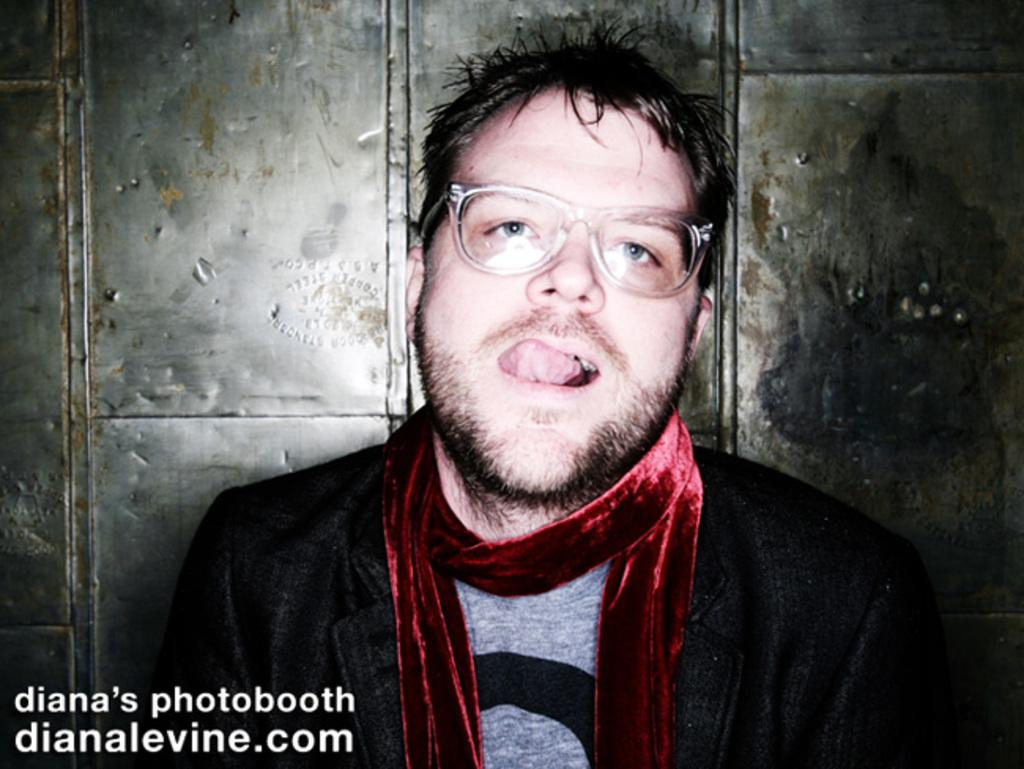Who or what is the main subject in the image? There is a person in the image. What can be seen in the background of the image? There is a metal wall in the background of the image. Where is the text located in the image? The text is in the left side bottom of the image. How many flowers are present in the image? There are no flowers visible in the image. What type of quiver is the person holding in the image? There is no quiver present in the image. 